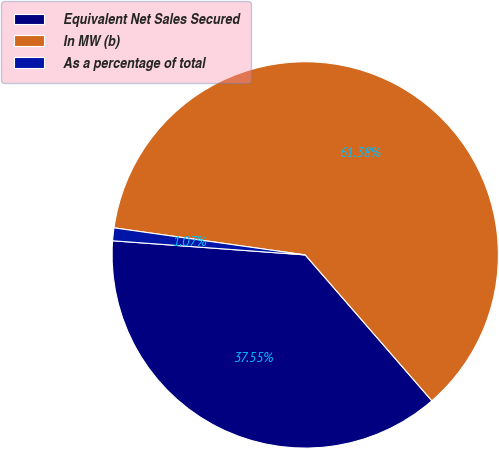Convert chart to OTSL. <chart><loc_0><loc_0><loc_500><loc_500><pie_chart><fcel>Equivalent Net Sales Secured<fcel>In MW (b)<fcel>As a percentage of total<nl><fcel>37.55%<fcel>61.39%<fcel>1.07%<nl></chart> 